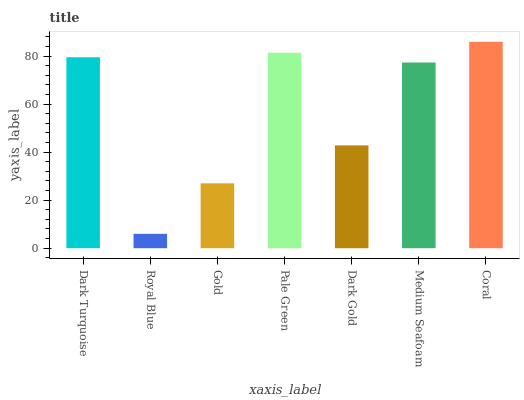Is Royal Blue the minimum?
Answer yes or no. Yes. Is Coral the maximum?
Answer yes or no. Yes. Is Gold the minimum?
Answer yes or no. No. Is Gold the maximum?
Answer yes or no. No. Is Gold greater than Royal Blue?
Answer yes or no. Yes. Is Royal Blue less than Gold?
Answer yes or no. Yes. Is Royal Blue greater than Gold?
Answer yes or no. No. Is Gold less than Royal Blue?
Answer yes or no. No. Is Medium Seafoam the high median?
Answer yes or no. Yes. Is Medium Seafoam the low median?
Answer yes or no. Yes. Is Dark Turquoise the high median?
Answer yes or no. No. Is Dark Gold the low median?
Answer yes or no. No. 